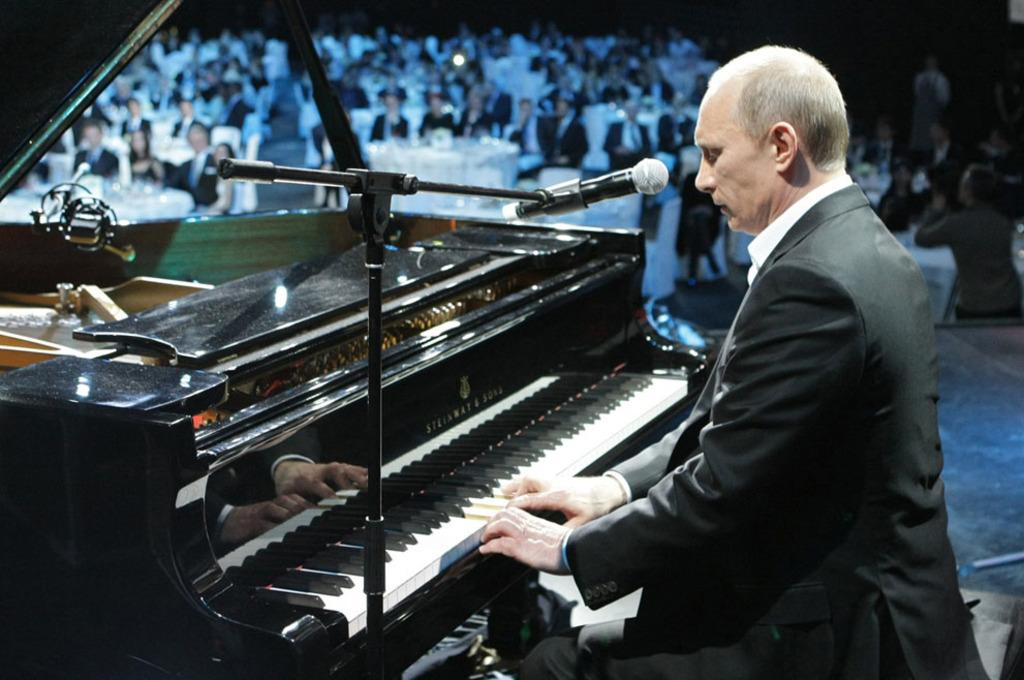What is the man in the image doing? The man in the image is playing a piano and singing on a mic. What might the people sitting in front of the man be doing? The people sitting in front of the man are likely listening to his performance, as they are looking at him. What is the man's primary activity in the image? The man's primary activity in the image is playing the piano and singing. Can you tell me how many goats are present in the image? There are no goats present in the image. What type of agreement is the man singing about in the image? The image does not provide any information about the content of the man's song or any agreements he might be singing about. 